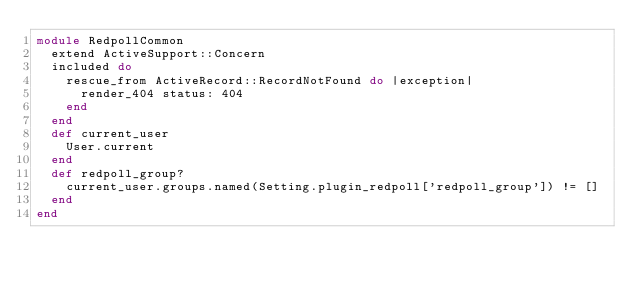<code> <loc_0><loc_0><loc_500><loc_500><_Ruby_>module RedpollCommon
  extend ActiveSupport::Concern
  included do 
    rescue_from ActiveRecord::RecordNotFound do |exception|
      render_404 status: 404
    end
  end
  def current_user
    User.current
  end
  def redpoll_group?
    current_user.groups.named(Setting.plugin_redpoll['redpoll_group']) != []
  end
end
</code> 